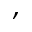Convert formula to latex. <formula><loc_0><loc_0><loc_500><loc_500>,</formula> 